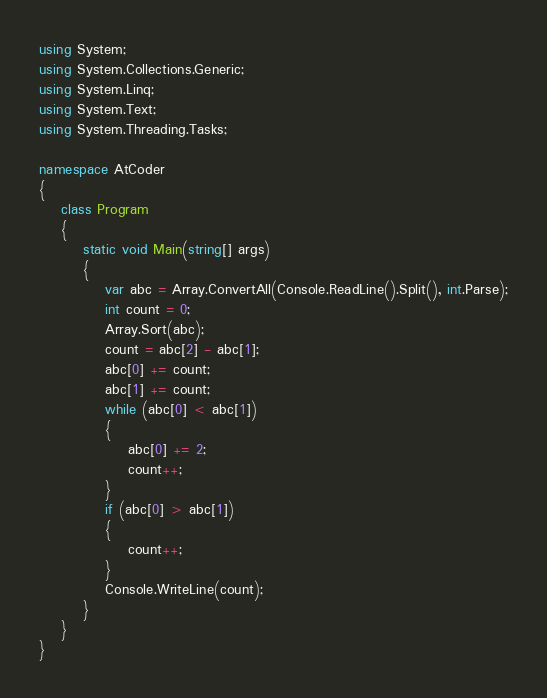Convert code to text. <code><loc_0><loc_0><loc_500><loc_500><_C#_>using System;
using System.Collections.Generic;
using System.Linq;
using System.Text;
using System.Threading.Tasks;

namespace AtCoder
{
    class Program
    {
        static void Main(string[] args)
        {
            var abc = Array.ConvertAll(Console.ReadLine().Split(), int.Parse);
            int count = 0;
            Array.Sort(abc);
            count = abc[2] - abc[1];
            abc[0] += count;
            abc[1] += count;
            while (abc[0] < abc[1])
            {
                abc[0] += 2;
                count++;
            }
            if (abc[0] > abc[1])
            {
                count++;
            }
            Console.WriteLine(count);
        }
    }
}</code> 